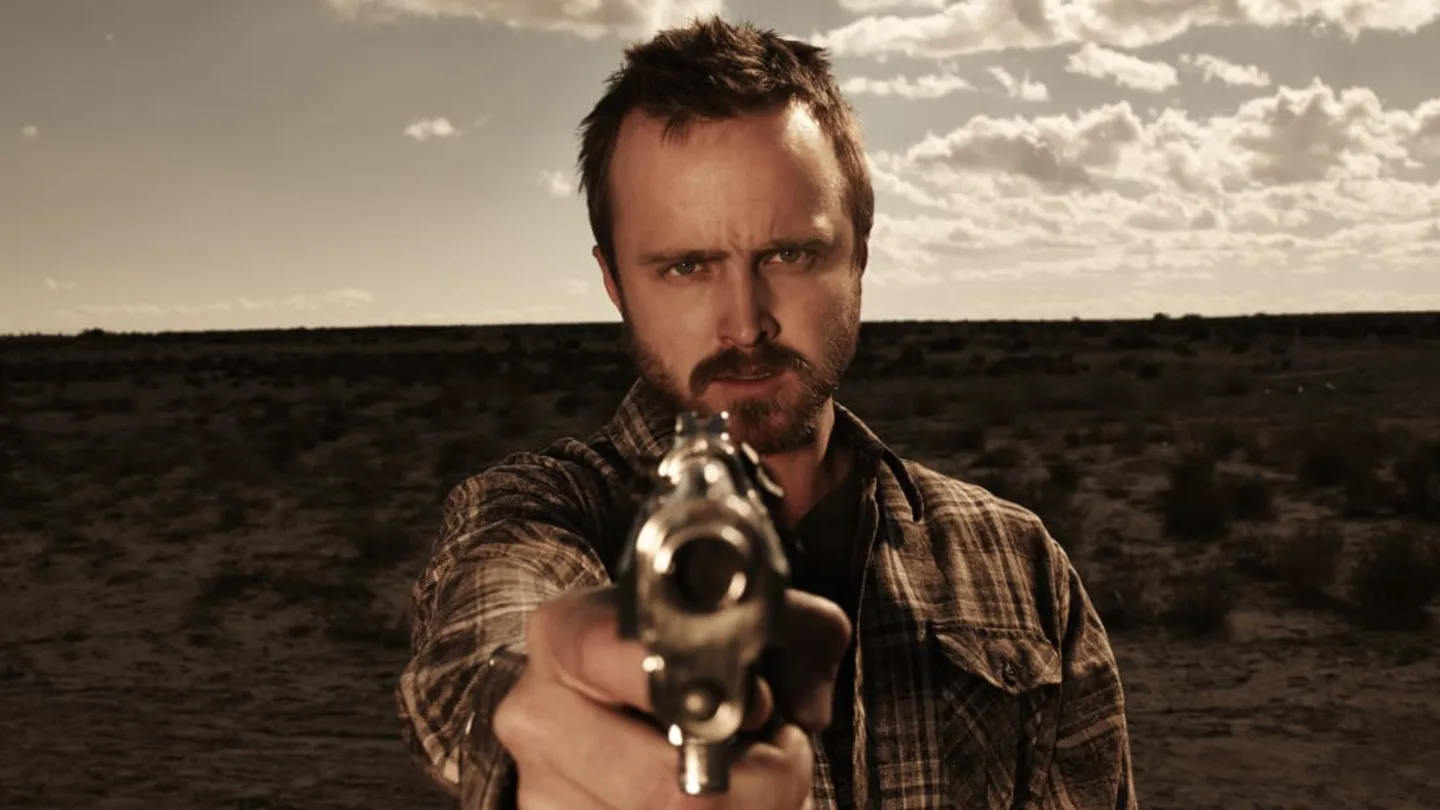What emotions does the subject in the image seem to portray? The subject in the image portrays a sense of intense determination and seriousness. His eyes are focused and his facial expression reveals a mix of resolve and perhaps a hint of aggression, which is amplified by the action of pointing a gun. 